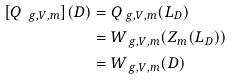<formula> <loc_0><loc_0><loc_500><loc_500>[ Q _ { \ g , V , m } ] ( D ) & = Q _ { \ g , V , m } ( L _ { D } ) \\ & = W _ { \ g , V , m } ( Z _ { m } ( L _ { D } ) ) \\ & = W _ { \ g , V , m } ( D )</formula> 